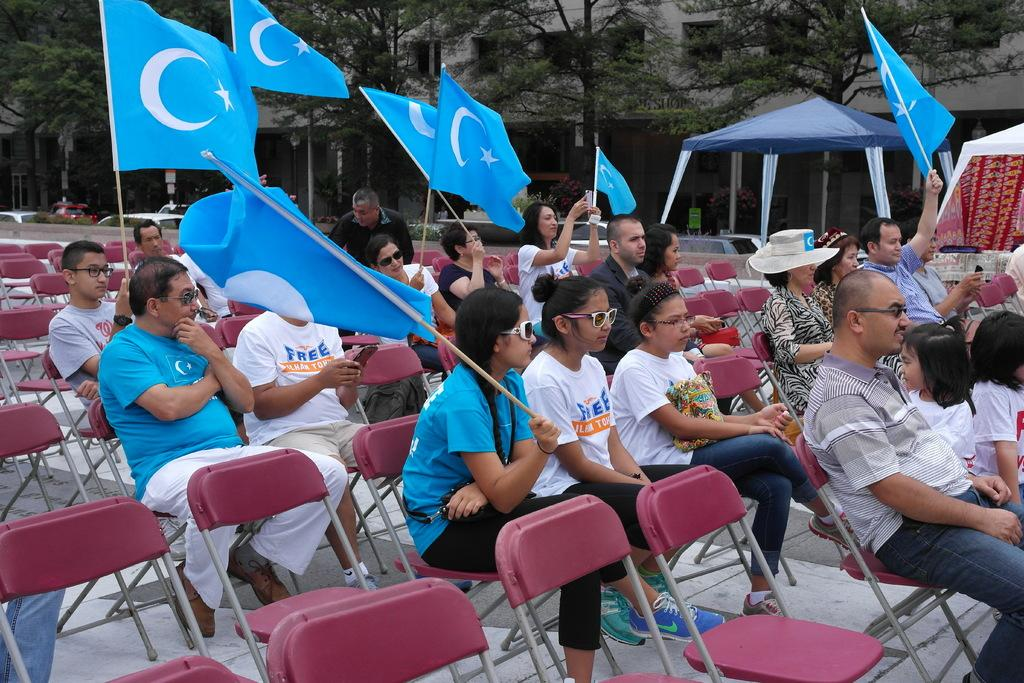What is happening in the image involving the group of people? The people in the image are seated on chairs and holding flags in their hands. Can you describe the setting of the image? There are trees and at least one building visible in the image. How many people are in the group? The number of people in the group is not specified, but there is a group of people present. What type of vest is the boy wearing in the image? There is no boy present in the image, and therefore no vest can be observed. 